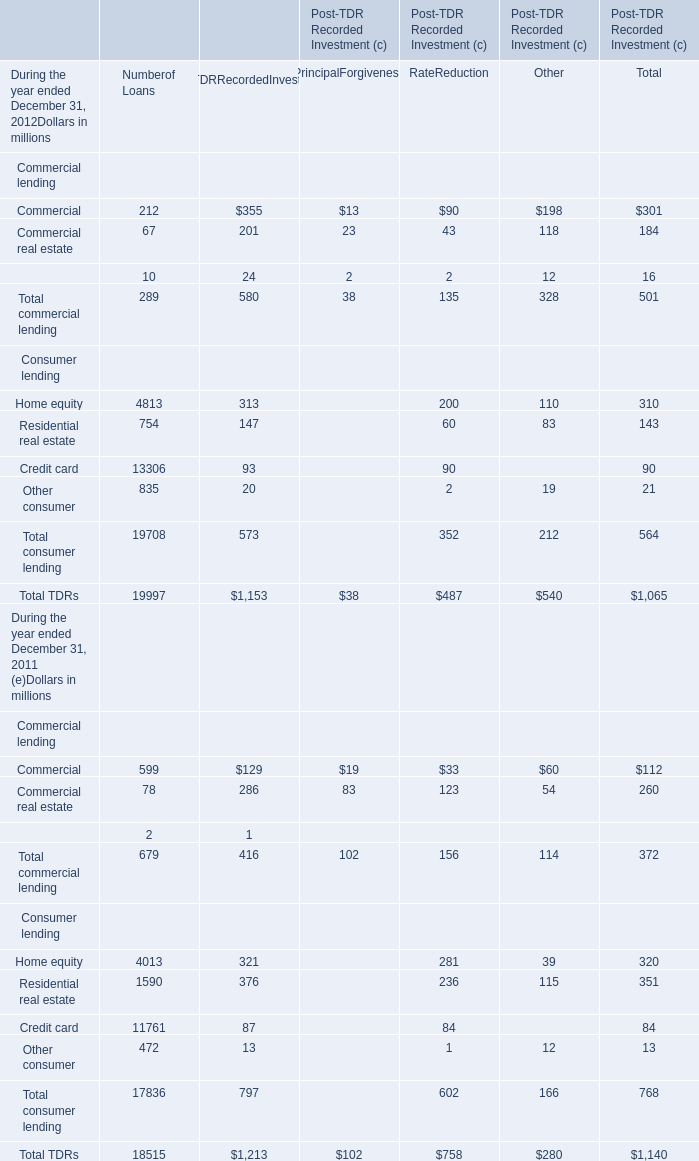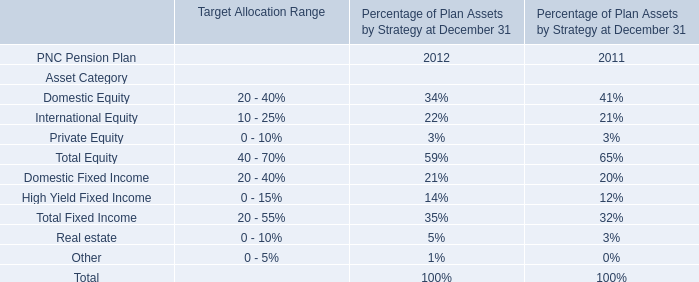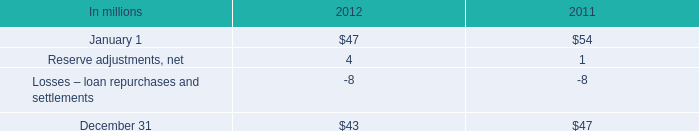As As the chart 0 shows,during the year ended December 31, 2012,what is the value of the Total consumer lending for Rate Reduction ? (in million) 
Answer: 352. 